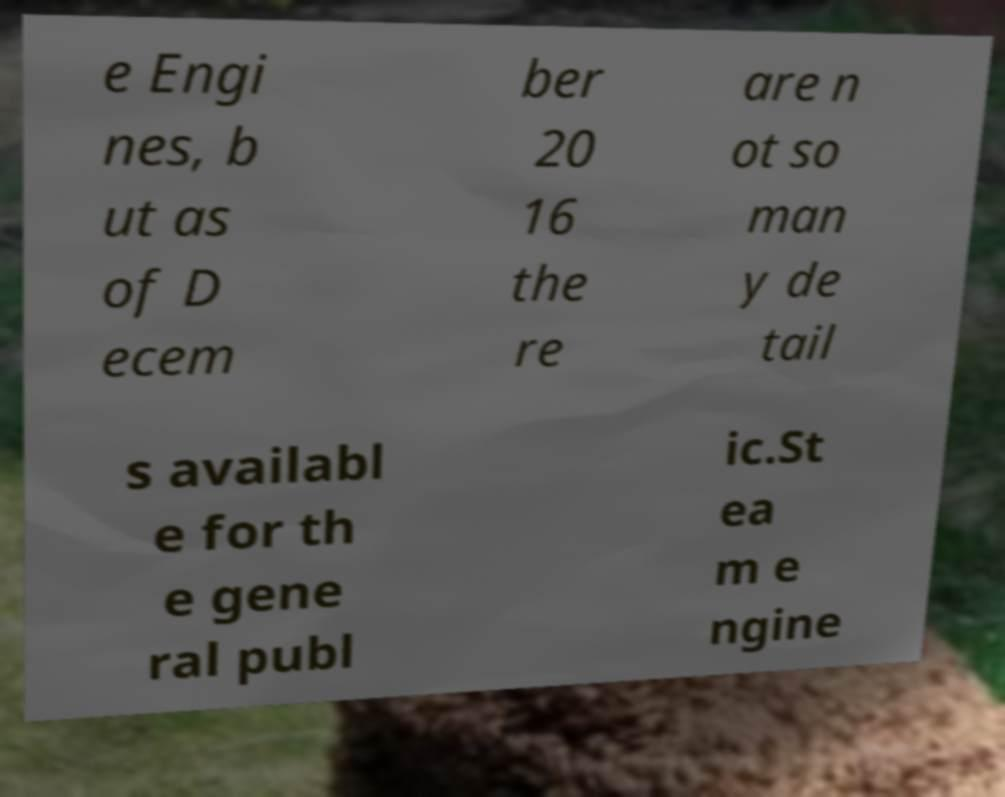Could you extract and type out the text from this image? e Engi nes, b ut as of D ecem ber 20 16 the re are n ot so man y de tail s availabl e for th e gene ral publ ic.St ea m e ngine 